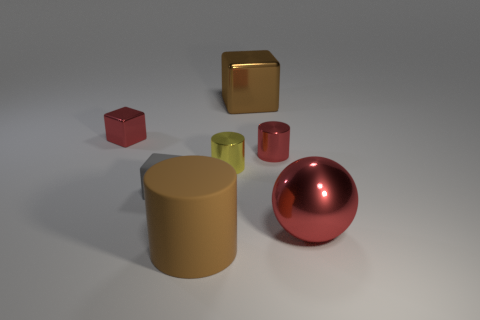Subtract all tiny cubes. How many cubes are left? 1 Add 3 small metal cylinders. How many objects exist? 10 Subtract all small gray cylinders. Subtract all brown rubber cylinders. How many objects are left? 6 Add 6 tiny gray matte things. How many tiny gray matte things are left? 7 Add 3 tiny red cylinders. How many tiny red cylinders exist? 4 Subtract 0 blue cubes. How many objects are left? 7 Subtract all cubes. How many objects are left? 4 